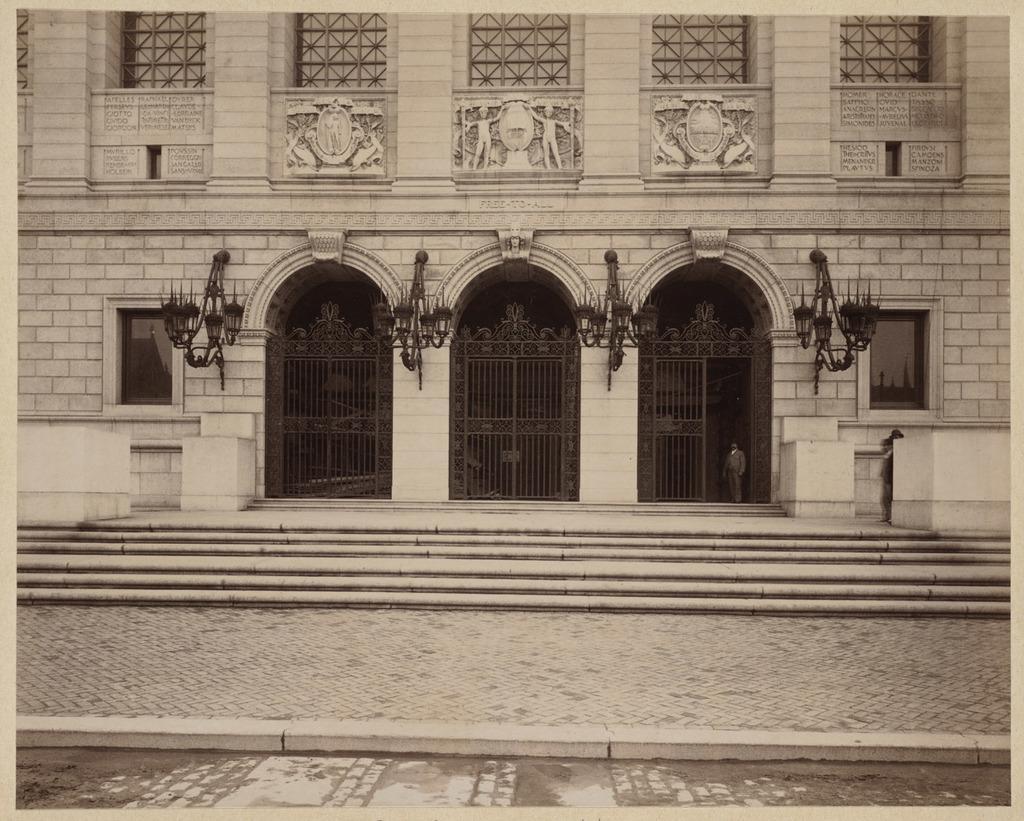In one or two sentences, can you explain what this image depicts? In this picture we can see a footpath, steps, gates, lights, windows, building and some objects and a person standing. 